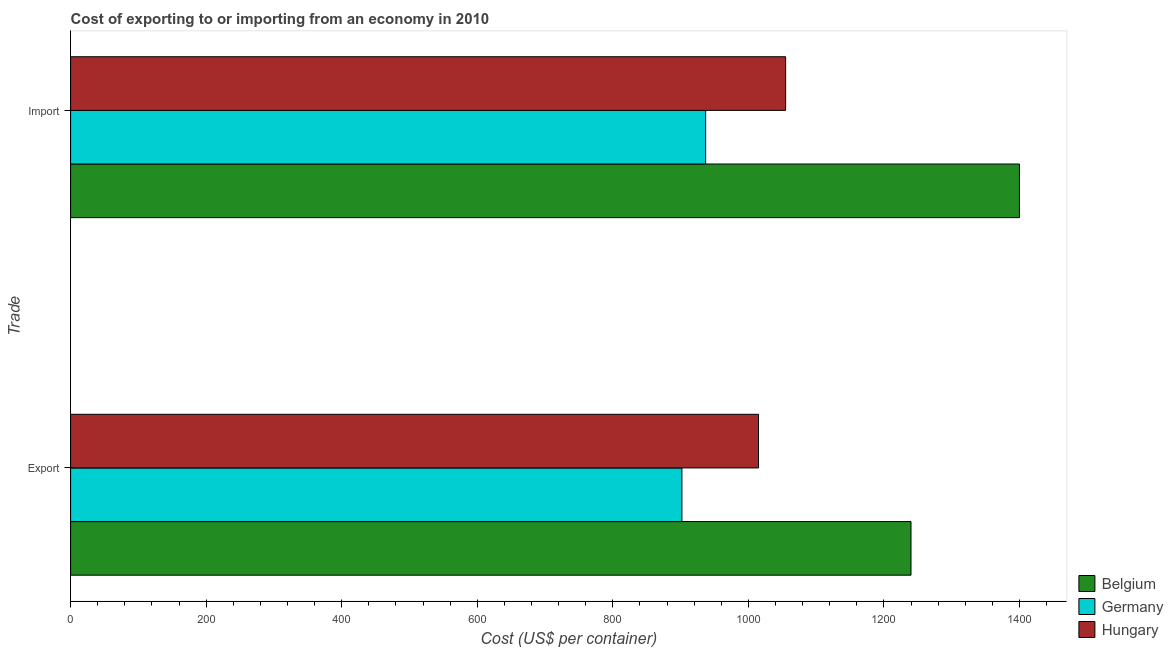How many different coloured bars are there?
Make the answer very short. 3. Are the number of bars per tick equal to the number of legend labels?
Keep it short and to the point. Yes. How many bars are there on the 2nd tick from the top?
Provide a succinct answer. 3. What is the label of the 2nd group of bars from the top?
Your answer should be compact. Export. What is the import cost in Germany?
Your answer should be compact. 937. Across all countries, what is the maximum export cost?
Offer a terse response. 1240. Across all countries, what is the minimum export cost?
Offer a very short reply. 902. In which country was the import cost minimum?
Make the answer very short. Germany. What is the total import cost in the graph?
Offer a terse response. 3392. What is the difference between the import cost in Hungary and that in Germany?
Provide a succinct answer. 118. What is the difference between the import cost in Hungary and the export cost in Belgium?
Your answer should be very brief. -185. What is the average export cost per country?
Your response must be concise. 1052.33. What is the difference between the import cost and export cost in Hungary?
Offer a terse response. 40. In how many countries, is the import cost greater than 560 US$?
Keep it short and to the point. 3. What is the ratio of the import cost in Belgium to that in Germany?
Keep it short and to the point. 1.49. Is the export cost in Belgium less than that in Germany?
Provide a short and direct response. No. In how many countries, is the export cost greater than the average export cost taken over all countries?
Your answer should be very brief. 1. What does the 2nd bar from the top in Import represents?
Your response must be concise. Germany. What does the 3rd bar from the bottom in Export represents?
Ensure brevity in your answer.  Hungary. How many countries are there in the graph?
Your answer should be compact. 3. Are the values on the major ticks of X-axis written in scientific E-notation?
Provide a short and direct response. No. Does the graph contain any zero values?
Your answer should be compact. No. Does the graph contain grids?
Your answer should be very brief. No. How many legend labels are there?
Your response must be concise. 3. How are the legend labels stacked?
Your response must be concise. Vertical. What is the title of the graph?
Your response must be concise. Cost of exporting to or importing from an economy in 2010. Does "Uzbekistan" appear as one of the legend labels in the graph?
Make the answer very short. No. What is the label or title of the X-axis?
Offer a very short reply. Cost (US$ per container). What is the label or title of the Y-axis?
Keep it short and to the point. Trade. What is the Cost (US$ per container) of Belgium in Export?
Your response must be concise. 1240. What is the Cost (US$ per container) in Germany in Export?
Offer a very short reply. 902. What is the Cost (US$ per container) of Hungary in Export?
Ensure brevity in your answer.  1015. What is the Cost (US$ per container) in Belgium in Import?
Your answer should be very brief. 1400. What is the Cost (US$ per container) in Germany in Import?
Make the answer very short. 937. What is the Cost (US$ per container) of Hungary in Import?
Your response must be concise. 1055. Across all Trade, what is the maximum Cost (US$ per container) in Belgium?
Offer a very short reply. 1400. Across all Trade, what is the maximum Cost (US$ per container) in Germany?
Your answer should be compact. 937. Across all Trade, what is the maximum Cost (US$ per container) in Hungary?
Your answer should be compact. 1055. Across all Trade, what is the minimum Cost (US$ per container) of Belgium?
Provide a succinct answer. 1240. Across all Trade, what is the minimum Cost (US$ per container) of Germany?
Your response must be concise. 902. Across all Trade, what is the minimum Cost (US$ per container) of Hungary?
Provide a short and direct response. 1015. What is the total Cost (US$ per container) of Belgium in the graph?
Offer a terse response. 2640. What is the total Cost (US$ per container) in Germany in the graph?
Keep it short and to the point. 1839. What is the total Cost (US$ per container) of Hungary in the graph?
Give a very brief answer. 2070. What is the difference between the Cost (US$ per container) in Belgium in Export and that in Import?
Ensure brevity in your answer.  -160. What is the difference between the Cost (US$ per container) of Germany in Export and that in Import?
Your answer should be very brief. -35. What is the difference between the Cost (US$ per container) of Hungary in Export and that in Import?
Offer a very short reply. -40. What is the difference between the Cost (US$ per container) of Belgium in Export and the Cost (US$ per container) of Germany in Import?
Provide a succinct answer. 303. What is the difference between the Cost (US$ per container) in Belgium in Export and the Cost (US$ per container) in Hungary in Import?
Give a very brief answer. 185. What is the difference between the Cost (US$ per container) of Germany in Export and the Cost (US$ per container) of Hungary in Import?
Your answer should be very brief. -153. What is the average Cost (US$ per container) in Belgium per Trade?
Your answer should be compact. 1320. What is the average Cost (US$ per container) in Germany per Trade?
Ensure brevity in your answer.  919.5. What is the average Cost (US$ per container) in Hungary per Trade?
Give a very brief answer. 1035. What is the difference between the Cost (US$ per container) in Belgium and Cost (US$ per container) in Germany in Export?
Your answer should be very brief. 338. What is the difference between the Cost (US$ per container) in Belgium and Cost (US$ per container) in Hungary in Export?
Provide a short and direct response. 225. What is the difference between the Cost (US$ per container) in Germany and Cost (US$ per container) in Hungary in Export?
Your response must be concise. -113. What is the difference between the Cost (US$ per container) of Belgium and Cost (US$ per container) of Germany in Import?
Your answer should be very brief. 463. What is the difference between the Cost (US$ per container) in Belgium and Cost (US$ per container) in Hungary in Import?
Give a very brief answer. 345. What is the difference between the Cost (US$ per container) of Germany and Cost (US$ per container) of Hungary in Import?
Offer a terse response. -118. What is the ratio of the Cost (US$ per container) of Belgium in Export to that in Import?
Provide a succinct answer. 0.89. What is the ratio of the Cost (US$ per container) of Germany in Export to that in Import?
Offer a very short reply. 0.96. What is the ratio of the Cost (US$ per container) of Hungary in Export to that in Import?
Offer a very short reply. 0.96. What is the difference between the highest and the second highest Cost (US$ per container) in Belgium?
Your answer should be very brief. 160. What is the difference between the highest and the second highest Cost (US$ per container) in Hungary?
Offer a terse response. 40. What is the difference between the highest and the lowest Cost (US$ per container) of Belgium?
Give a very brief answer. 160. What is the difference between the highest and the lowest Cost (US$ per container) in Germany?
Give a very brief answer. 35. What is the difference between the highest and the lowest Cost (US$ per container) in Hungary?
Make the answer very short. 40. 